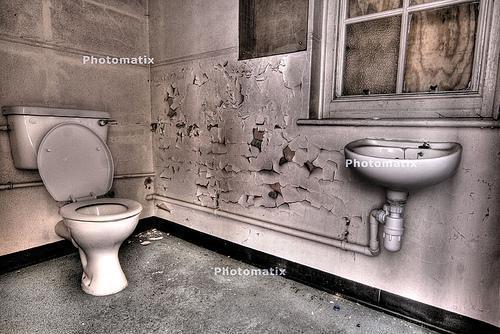How many sinks are pictured?
Give a very brief answer. 1. How many toilets are here?
Give a very brief answer. 1. How many people are in this picture?
Give a very brief answer. 0. 